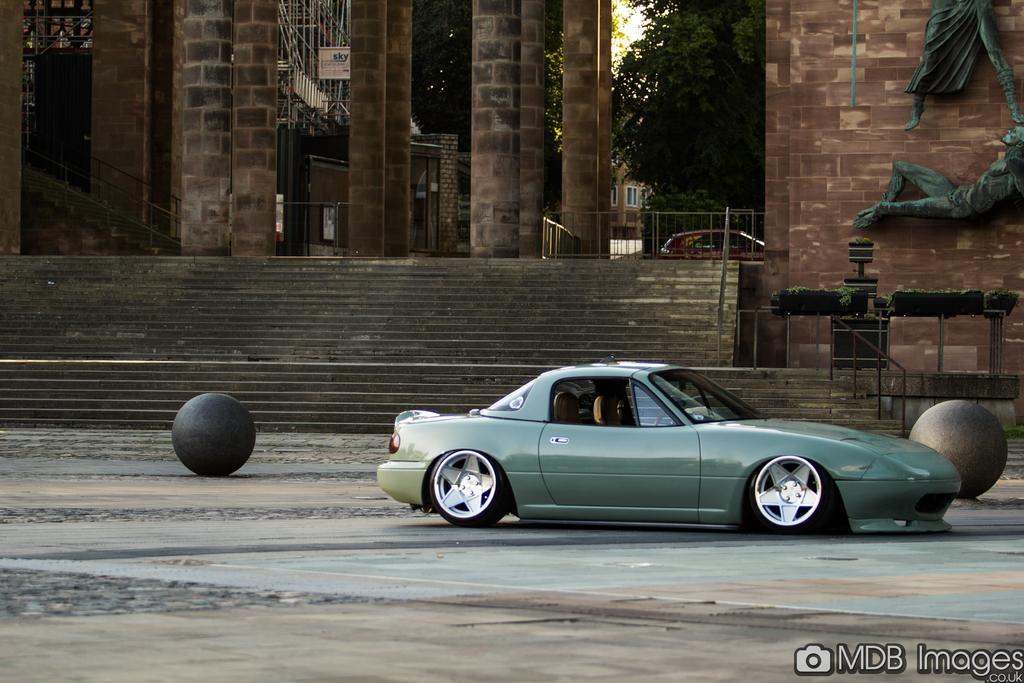How would you summarize this image in a sentence or two? Here we can see vehicles, steps, walls, boards, tree, windows and railing. On this wall there are statues. These are plants.  